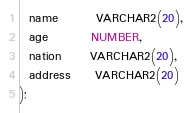<code> <loc_0><loc_0><loc_500><loc_500><_SQL_>  name        VARCHAR2(20),
  age         NUMBER,
  nation      VARCHAR2(20),
  address     VARCHAR2(20)
);

</code> 